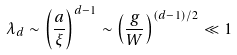<formula> <loc_0><loc_0><loc_500><loc_500>\lambda _ { d } \sim \left ( \frac { a } { \xi } \right ) ^ { d - 1 } \sim \left ( \frac { g } { W } \right ) ^ { ( d - 1 ) / 2 } \ll 1</formula> 